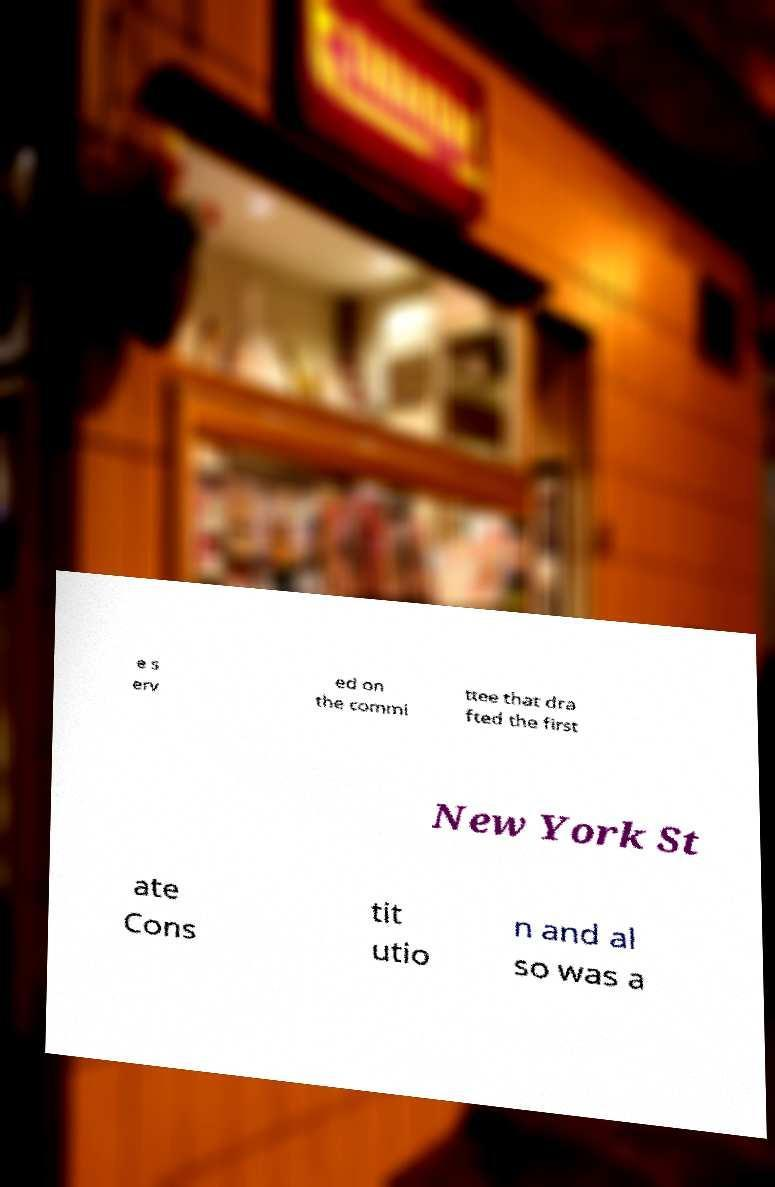Could you assist in decoding the text presented in this image and type it out clearly? e s erv ed on the commi ttee that dra fted the first New York St ate Cons tit utio n and al so was a 